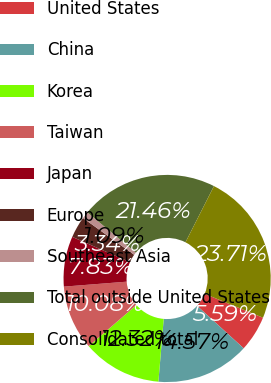Convert chart. <chart><loc_0><loc_0><loc_500><loc_500><pie_chart><fcel>United States<fcel>China<fcel>Korea<fcel>Taiwan<fcel>Japan<fcel>Europe<fcel>Southeast Asia<fcel>Total outside United States<fcel>Consolidated total<nl><fcel>5.59%<fcel>14.57%<fcel>12.32%<fcel>10.08%<fcel>7.83%<fcel>3.34%<fcel>1.09%<fcel>21.46%<fcel>23.71%<nl></chart> 